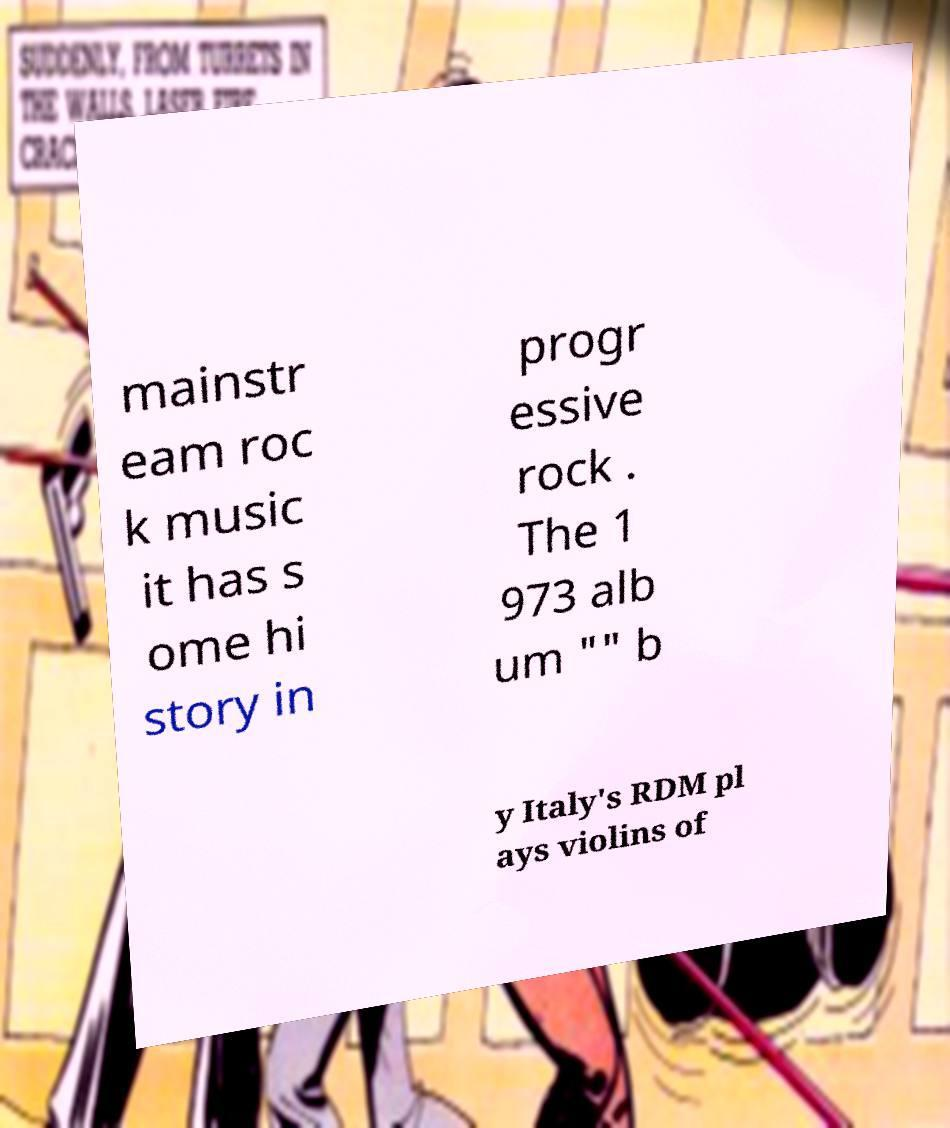I need the written content from this picture converted into text. Can you do that? mainstr eam roc k music it has s ome hi story in progr essive rock . The 1 973 alb um "" b y Italy's RDM pl ays violins of 